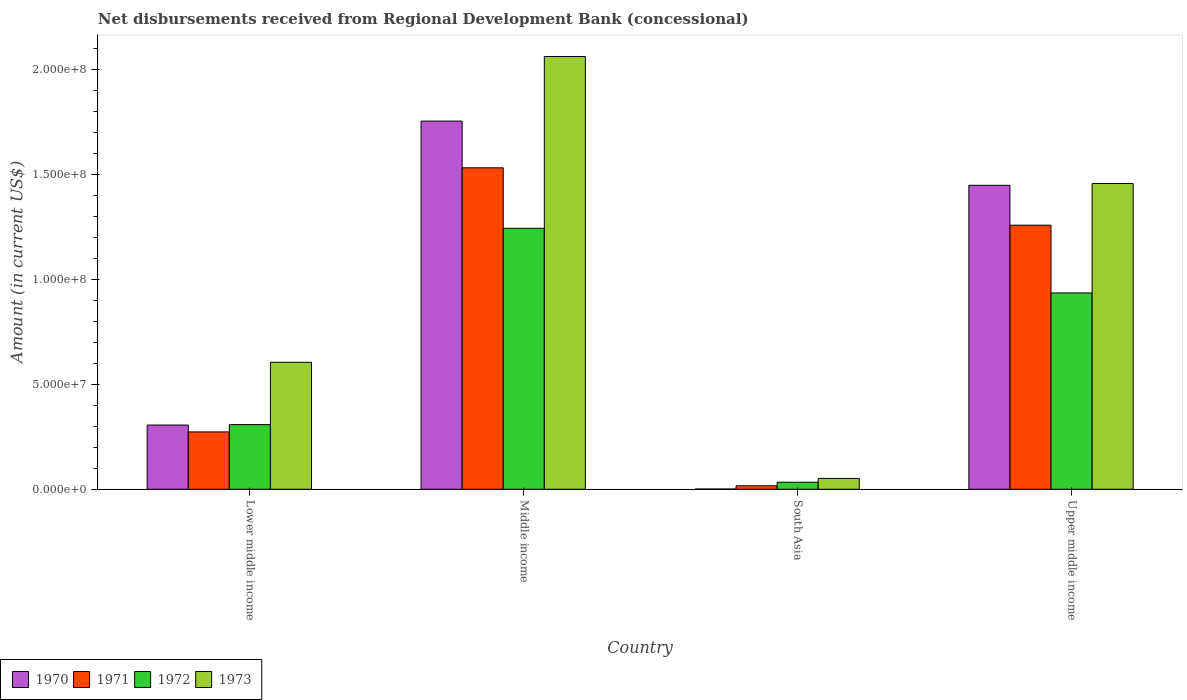Are the number of bars per tick equal to the number of legend labels?
Your answer should be compact. Yes. How many bars are there on the 1st tick from the right?
Your answer should be compact. 4. What is the amount of disbursements received from Regional Development Bank in 1972 in South Asia?
Your answer should be compact. 3.35e+06. Across all countries, what is the maximum amount of disbursements received from Regional Development Bank in 1970?
Your answer should be compact. 1.76e+08. Across all countries, what is the minimum amount of disbursements received from Regional Development Bank in 1970?
Keep it short and to the point. 1.09e+05. In which country was the amount of disbursements received from Regional Development Bank in 1973 minimum?
Your answer should be compact. South Asia. What is the total amount of disbursements received from Regional Development Bank in 1970 in the graph?
Give a very brief answer. 3.51e+08. What is the difference between the amount of disbursements received from Regional Development Bank in 1972 in Middle income and that in Upper middle income?
Your answer should be very brief. 3.08e+07. What is the difference between the amount of disbursements received from Regional Development Bank in 1971 in Upper middle income and the amount of disbursements received from Regional Development Bank in 1970 in Middle income?
Give a very brief answer. -4.96e+07. What is the average amount of disbursements received from Regional Development Bank in 1971 per country?
Offer a very short reply. 7.70e+07. What is the difference between the amount of disbursements received from Regional Development Bank of/in 1971 and amount of disbursements received from Regional Development Bank of/in 1970 in South Asia?
Your answer should be very brief. 1.54e+06. What is the ratio of the amount of disbursements received from Regional Development Bank in 1970 in South Asia to that in Upper middle income?
Your answer should be very brief. 0. Is the amount of disbursements received from Regional Development Bank in 1973 in Middle income less than that in Upper middle income?
Your answer should be very brief. No. Is the difference between the amount of disbursements received from Regional Development Bank in 1971 in Middle income and Upper middle income greater than the difference between the amount of disbursements received from Regional Development Bank in 1970 in Middle income and Upper middle income?
Make the answer very short. No. What is the difference between the highest and the second highest amount of disbursements received from Regional Development Bank in 1970?
Keep it short and to the point. 1.45e+08. What is the difference between the highest and the lowest amount of disbursements received from Regional Development Bank in 1972?
Your answer should be compact. 1.21e+08. In how many countries, is the amount of disbursements received from Regional Development Bank in 1971 greater than the average amount of disbursements received from Regional Development Bank in 1971 taken over all countries?
Ensure brevity in your answer.  2. What does the 3rd bar from the left in Lower middle income represents?
Offer a very short reply. 1972. What does the 4th bar from the right in Upper middle income represents?
Your answer should be compact. 1970. Is it the case that in every country, the sum of the amount of disbursements received from Regional Development Bank in 1973 and amount of disbursements received from Regional Development Bank in 1972 is greater than the amount of disbursements received from Regional Development Bank in 1970?
Provide a short and direct response. Yes. Are all the bars in the graph horizontal?
Ensure brevity in your answer.  No. How many countries are there in the graph?
Your answer should be compact. 4. What is the difference between two consecutive major ticks on the Y-axis?
Provide a succinct answer. 5.00e+07. Does the graph contain any zero values?
Provide a succinct answer. No. How many legend labels are there?
Ensure brevity in your answer.  4. How are the legend labels stacked?
Offer a very short reply. Horizontal. What is the title of the graph?
Make the answer very short. Net disbursements received from Regional Development Bank (concessional). Does "1967" appear as one of the legend labels in the graph?
Keep it short and to the point. No. What is the label or title of the Y-axis?
Give a very brief answer. Amount (in current US$). What is the Amount (in current US$) of 1970 in Lower middle income?
Make the answer very short. 3.06e+07. What is the Amount (in current US$) in 1971 in Lower middle income?
Your response must be concise. 2.74e+07. What is the Amount (in current US$) in 1972 in Lower middle income?
Give a very brief answer. 3.08e+07. What is the Amount (in current US$) of 1973 in Lower middle income?
Offer a terse response. 6.06e+07. What is the Amount (in current US$) of 1970 in Middle income?
Offer a terse response. 1.76e+08. What is the Amount (in current US$) of 1971 in Middle income?
Provide a short and direct response. 1.53e+08. What is the Amount (in current US$) in 1972 in Middle income?
Give a very brief answer. 1.24e+08. What is the Amount (in current US$) in 1973 in Middle income?
Your response must be concise. 2.06e+08. What is the Amount (in current US$) in 1970 in South Asia?
Keep it short and to the point. 1.09e+05. What is the Amount (in current US$) of 1971 in South Asia?
Your answer should be very brief. 1.65e+06. What is the Amount (in current US$) of 1972 in South Asia?
Provide a succinct answer. 3.35e+06. What is the Amount (in current US$) of 1973 in South Asia?
Your response must be concise. 5.18e+06. What is the Amount (in current US$) in 1970 in Upper middle income?
Your answer should be very brief. 1.45e+08. What is the Amount (in current US$) of 1971 in Upper middle income?
Offer a terse response. 1.26e+08. What is the Amount (in current US$) of 1972 in Upper middle income?
Make the answer very short. 9.36e+07. What is the Amount (in current US$) in 1973 in Upper middle income?
Provide a short and direct response. 1.46e+08. Across all countries, what is the maximum Amount (in current US$) in 1970?
Keep it short and to the point. 1.76e+08. Across all countries, what is the maximum Amount (in current US$) in 1971?
Offer a very short reply. 1.53e+08. Across all countries, what is the maximum Amount (in current US$) in 1972?
Your response must be concise. 1.24e+08. Across all countries, what is the maximum Amount (in current US$) of 1973?
Provide a succinct answer. 2.06e+08. Across all countries, what is the minimum Amount (in current US$) of 1970?
Make the answer very short. 1.09e+05. Across all countries, what is the minimum Amount (in current US$) in 1971?
Give a very brief answer. 1.65e+06. Across all countries, what is the minimum Amount (in current US$) of 1972?
Make the answer very short. 3.35e+06. Across all countries, what is the minimum Amount (in current US$) in 1973?
Give a very brief answer. 5.18e+06. What is the total Amount (in current US$) of 1970 in the graph?
Give a very brief answer. 3.51e+08. What is the total Amount (in current US$) of 1971 in the graph?
Offer a very short reply. 3.08e+08. What is the total Amount (in current US$) of 1972 in the graph?
Your answer should be compact. 2.52e+08. What is the total Amount (in current US$) in 1973 in the graph?
Your answer should be very brief. 4.18e+08. What is the difference between the Amount (in current US$) in 1970 in Lower middle income and that in Middle income?
Your answer should be compact. -1.45e+08. What is the difference between the Amount (in current US$) of 1971 in Lower middle income and that in Middle income?
Provide a succinct answer. -1.26e+08. What is the difference between the Amount (in current US$) in 1972 in Lower middle income and that in Middle income?
Provide a short and direct response. -9.36e+07. What is the difference between the Amount (in current US$) in 1973 in Lower middle income and that in Middle income?
Your answer should be very brief. -1.46e+08. What is the difference between the Amount (in current US$) in 1970 in Lower middle income and that in South Asia?
Your answer should be very brief. 3.05e+07. What is the difference between the Amount (in current US$) of 1971 in Lower middle income and that in South Asia?
Provide a short and direct response. 2.57e+07. What is the difference between the Amount (in current US$) in 1972 in Lower middle income and that in South Asia?
Provide a succinct answer. 2.75e+07. What is the difference between the Amount (in current US$) of 1973 in Lower middle income and that in South Asia?
Offer a very short reply. 5.54e+07. What is the difference between the Amount (in current US$) in 1970 in Lower middle income and that in Upper middle income?
Ensure brevity in your answer.  -1.14e+08. What is the difference between the Amount (in current US$) of 1971 in Lower middle income and that in Upper middle income?
Give a very brief answer. -9.86e+07. What is the difference between the Amount (in current US$) of 1972 in Lower middle income and that in Upper middle income?
Ensure brevity in your answer.  -6.28e+07. What is the difference between the Amount (in current US$) in 1973 in Lower middle income and that in Upper middle income?
Your answer should be compact. -8.52e+07. What is the difference between the Amount (in current US$) of 1970 in Middle income and that in South Asia?
Make the answer very short. 1.75e+08. What is the difference between the Amount (in current US$) of 1971 in Middle income and that in South Asia?
Keep it short and to the point. 1.52e+08. What is the difference between the Amount (in current US$) of 1972 in Middle income and that in South Asia?
Provide a short and direct response. 1.21e+08. What is the difference between the Amount (in current US$) in 1973 in Middle income and that in South Asia?
Offer a terse response. 2.01e+08. What is the difference between the Amount (in current US$) in 1970 in Middle income and that in Upper middle income?
Your response must be concise. 3.06e+07. What is the difference between the Amount (in current US$) in 1971 in Middle income and that in Upper middle income?
Offer a terse response. 2.74e+07. What is the difference between the Amount (in current US$) of 1972 in Middle income and that in Upper middle income?
Your answer should be compact. 3.08e+07. What is the difference between the Amount (in current US$) of 1973 in Middle income and that in Upper middle income?
Offer a terse response. 6.06e+07. What is the difference between the Amount (in current US$) in 1970 in South Asia and that in Upper middle income?
Your answer should be compact. -1.45e+08. What is the difference between the Amount (in current US$) in 1971 in South Asia and that in Upper middle income?
Offer a very short reply. -1.24e+08. What is the difference between the Amount (in current US$) of 1972 in South Asia and that in Upper middle income?
Your answer should be compact. -9.03e+07. What is the difference between the Amount (in current US$) of 1973 in South Asia and that in Upper middle income?
Give a very brief answer. -1.41e+08. What is the difference between the Amount (in current US$) in 1970 in Lower middle income and the Amount (in current US$) in 1971 in Middle income?
Offer a terse response. -1.23e+08. What is the difference between the Amount (in current US$) in 1970 in Lower middle income and the Amount (in current US$) in 1972 in Middle income?
Give a very brief answer. -9.38e+07. What is the difference between the Amount (in current US$) of 1970 in Lower middle income and the Amount (in current US$) of 1973 in Middle income?
Ensure brevity in your answer.  -1.76e+08. What is the difference between the Amount (in current US$) of 1971 in Lower middle income and the Amount (in current US$) of 1972 in Middle income?
Your response must be concise. -9.71e+07. What is the difference between the Amount (in current US$) of 1971 in Lower middle income and the Amount (in current US$) of 1973 in Middle income?
Offer a terse response. -1.79e+08. What is the difference between the Amount (in current US$) of 1972 in Lower middle income and the Amount (in current US$) of 1973 in Middle income?
Make the answer very short. -1.76e+08. What is the difference between the Amount (in current US$) of 1970 in Lower middle income and the Amount (in current US$) of 1971 in South Asia?
Keep it short and to the point. 2.90e+07. What is the difference between the Amount (in current US$) of 1970 in Lower middle income and the Amount (in current US$) of 1972 in South Asia?
Provide a short and direct response. 2.73e+07. What is the difference between the Amount (in current US$) in 1970 in Lower middle income and the Amount (in current US$) in 1973 in South Asia?
Offer a very short reply. 2.54e+07. What is the difference between the Amount (in current US$) of 1971 in Lower middle income and the Amount (in current US$) of 1972 in South Asia?
Make the answer very short. 2.40e+07. What is the difference between the Amount (in current US$) of 1971 in Lower middle income and the Amount (in current US$) of 1973 in South Asia?
Your answer should be compact. 2.22e+07. What is the difference between the Amount (in current US$) of 1972 in Lower middle income and the Amount (in current US$) of 1973 in South Asia?
Offer a very short reply. 2.56e+07. What is the difference between the Amount (in current US$) of 1970 in Lower middle income and the Amount (in current US$) of 1971 in Upper middle income?
Your answer should be very brief. -9.53e+07. What is the difference between the Amount (in current US$) of 1970 in Lower middle income and the Amount (in current US$) of 1972 in Upper middle income?
Provide a succinct answer. -6.30e+07. What is the difference between the Amount (in current US$) of 1970 in Lower middle income and the Amount (in current US$) of 1973 in Upper middle income?
Offer a very short reply. -1.15e+08. What is the difference between the Amount (in current US$) in 1971 in Lower middle income and the Amount (in current US$) in 1972 in Upper middle income?
Make the answer very short. -6.63e+07. What is the difference between the Amount (in current US$) of 1971 in Lower middle income and the Amount (in current US$) of 1973 in Upper middle income?
Give a very brief answer. -1.18e+08. What is the difference between the Amount (in current US$) of 1972 in Lower middle income and the Amount (in current US$) of 1973 in Upper middle income?
Keep it short and to the point. -1.15e+08. What is the difference between the Amount (in current US$) of 1970 in Middle income and the Amount (in current US$) of 1971 in South Asia?
Offer a very short reply. 1.74e+08. What is the difference between the Amount (in current US$) in 1970 in Middle income and the Amount (in current US$) in 1972 in South Asia?
Offer a terse response. 1.72e+08. What is the difference between the Amount (in current US$) in 1970 in Middle income and the Amount (in current US$) in 1973 in South Asia?
Give a very brief answer. 1.70e+08. What is the difference between the Amount (in current US$) in 1971 in Middle income and the Amount (in current US$) in 1972 in South Asia?
Keep it short and to the point. 1.50e+08. What is the difference between the Amount (in current US$) in 1971 in Middle income and the Amount (in current US$) in 1973 in South Asia?
Your response must be concise. 1.48e+08. What is the difference between the Amount (in current US$) of 1972 in Middle income and the Amount (in current US$) of 1973 in South Asia?
Ensure brevity in your answer.  1.19e+08. What is the difference between the Amount (in current US$) in 1970 in Middle income and the Amount (in current US$) in 1971 in Upper middle income?
Provide a succinct answer. 4.96e+07. What is the difference between the Amount (in current US$) of 1970 in Middle income and the Amount (in current US$) of 1972 in Upper middle income?
Your response must be concise. 8.19e+07. What is the difference between the Amount (in current US$) of 1970 in Middle income and the Amount (in current US$) of 1973 in Upper middle income?
Give a very brief answer. 2.98e+07. What is the difference between the Amount (in current US$) of 1971 in Middle income and the Amount (in current US$) of 1972 in Upper middle income?
Offer a very short reply. 5.97e+07. What is the difference between the Amount (in current US$) of 1971 in Middle income and the Amount (in current US$) of 1973 in Upper middle income?
Provide a short and direct response. 7.49e+06. What is the difference between the Amount (in current US$) in 1972 in Middle income and the Amount (in current US$) in 1973 in Upper middle income?
Your answer should be compact. -2.14e+07. What is the difference between the Amount (in current US$) of 1970 in South Asia and the Amount (in current US$) of 1971 in Upper middle income?
Make the answer very short. -1.26e+08. What is the difference between the Amount (in current US$) of 1970 in South Asia and the Amount (in current US$) of 1972 in Upper middle income?
Ensure brevity in your answer.  -9.35e+07. What is the difference between the Amount (in current US$) in 1970 in South Asia and the Amount (in current US$) in 1973 in Upper middle income?
Offer a very short reply. -1.46e+08. What is the difference between the Amount (in current US$) of 1971 in South Asia and the Amount (in current US$) of 1972 in Upper middle income?
Your response must be concise. -9.20e+07. What is the difference between the Amount (in current US$) of 1971 in South Asia and the Amount (in current US$) of 1973 in Upper middle income?
Make the answer very short. -1.44e+08. What is the difference between the Amount (in current US$) in 1972 in South Asia and the Amount (in current US$) in 1973 in Upper middle income?
Your response must be concise. -1.42e+08. What is the average Amount (in current US$) of 1970 per country?
Make the answer very short. 8.78e+07. What is the average Amount (in current US$) of 1971 per country?
Offer a very short reply. 7.70e+07. What is the average Amount (in current US$) of 1972 per country?
Keep it short and to the point. 6.31e+07. What is the average Amount (in current US$) of 1973 per country?
Offer a very short reply. 1.04e+08. What is the difference between the Amount (in current US$) of 1970 and Amount (in current US$) of 1971 in Lower middle income?
Your response must be concise. 3.27e+06. What is the difference between the Amount (in current US$) in 1970 and Amount (in current US$) in 1972 in Lower middle income?
Provide a succinct answer. -2.02e+05. What is the difference between the Amount (in current US$) of 1970 and Amount (in current US$) of 1973 in Lower middle income?
Your answer should be very brief. -2.99e+07. What is the difference between the Amount (in current US$) of 1971 and Amount (in current US$) of 1972 in Lower middle income?
Make the answer very short. -3.47e+06. What is the difference between the Amount (in current US$) in 1971 and Amount (in current US$) in 1973 in Lower middle income?
Offer a very short reply. -3.32e+07. What is the difference between the Amount (in current US$) in 1972 and Amount (in current US$) in 1973 in Lower middle income?
Ensure brevity in your answer.  -2.97e+07. What is the difference between the Amount (in current US$) in 1970 and Amount (in current US$) in 1971 in Middle income?
Make the answer very short. 2.23e+07. What is the difference between the Amount (in current US$) of 1970 and Amount (in current US$) of 1972 in Middle income?
Provide a short and direct response. 5.11e+07. What is the difference between the Amount (in current US$) in 1970 and Amount (in current US$) in 1973 in Middle income?
Your response must be concise. -3.08e+07. What is the difference between the Amount (in current US$) in 1971 and Amount (in current US$) in 1972 in Middle income?
Ensure brevity in your answer.  2.88e+07. What is the difference between the Amount (in current US$) of 1971 and Amount (in current US$) of 1973 in Middle income?
Offer a terse response. -5.31e+07. What is the difference between the Amount (in current US$) in 1972 and Amount (in current US$) in 1973 in Middle income?
Ensure brevity in your answer.  -8.19e+07. What is the difference between the Amount (in current US$) of 1970 and Amount (in current US$) of 1971 in South Asia?
Your answer should be very brief. -1.54e+06. What is the difference between the Amount (in current US$) of 1970 and Amount (in current US$) of 1972 in South Asia?
Ensure brevity in your answer.  -3.24e+06. What is the difference between the Amount (in current US$) of 1970 and Amount (in current US$) of 1973 in South Asia?
Offer a terse response. -5.08e+06. What is the difference between the Amount (in current US$) in 1971 and Amount (in current US$) in 1972 in South Asia?
Offer a very short reply. -1.70e+06. What is the difference between the Amount (in current US$) of 1971 and Amount (in current US$) of 1973 in South Asia?
Give a very brief answer. -3.53e+06. What is the difference between the Amount (in current US$) in 1972 and Amount (in current US$) in 1973 in South Asia?
Your answer should be very brief. -1.83e+06. What is the difference between the Amount (in current US$) of 1970 and Amount (in current US$) of 1971 in Upper middle income?
Keep it short and to the point. 1.90e+07. What is the difference between the Amount (in current US$) in 1970 and Amount (in current US$) in 1972 in Upper middle income?
Provide a short and direct response. 5.13e+07. What is the difference between the Amount (in current US$) of 1970 and Amount (in current US$) of 1973 in Upper middle income?
Make the answer very short. -8.58e+05. What is the difference between the Amount (in current US$) in 1971 and Amount (in current US$) in 1972 in Upper middle income?
Make the answer very short. 3.23e+07. What is the difference between the Amount (in current US$) in 1971 and Amount (in current US$) in 1973 in Upper middle income?
Provide a succinct answer. -1.99e+07. What is the difference between the Amount (in current US$) of 1972 and Amount (in current US$) of 1973 in Upper middle income?
Offer a very short reply. -5.22e+07. What is the ratio of the Amount (in current US$) of 1970 in Lower middle income to that in Middle income?
Your response must be concise. 0.17. What is the ratio of the Amount (in current US$) of 1971 in Lower middle income to that in Middle income?
Provide a succinct answer. 0.18. What is the ratio of the Amount (in current US$) in 1972 in Lower middle income to that in Middle income?
Offer a very short reply. 0.25. What is the ratio of the Amount (in current US$) in 1973 in Lower middle income to that in Middle income?
Give a very brief answer. 0.29. What is the ratio of the Amount (in current US$) of 1970 in Lower middle income to that in South Asia?
Offer a very short reply. 280.94. What is the ratio of the Amount (in current US$) in 1971 in Lower middle income to that in South Asia?
Provide a succinct answer. 16.58. What is the ratio of the Amount (in current US$) in 1972 in Lower middle income to that in South Asia?
Make the answer very short. 9.2. What is the ratio of the Amount (in current US$) in 1973 in Lower middle income to that in South Asia?
Offer a very short reply. 11.68. What is the ratio of the Amount (in current US$) of 1970 in Lower middle income to that in Upper middle income?
Offer a terse response. 0.21. What is the ratio of the Amount (in current US$) in 1971 in Lower middle income to that in Upper middle income?
Make the answer very short. 0.22. What is the ratio of the Amount (in current US$) of 1972 in Lower middle income to that in Upper middle income?
Give a very brief answer. 0.33. What is the ratio of the Amount (in current US$) of 1973 in Lower middle income to that in Upper middle income?
Give a very brief answer. 0.42. What is the ratio of the Amount (in current US$) in 1970 in Middle income to that in South Asia?
Your response must be concise. 1610.58. What is the ratio of the Amount (in current US$) of 1971 in Middle income to that in South Asia?
Your answer should be compact. 92.89. What is the ratio of the Amount (in current US$) in 1972 in Middle income to that in South Asia?
Your answer should be compact. 37.14. What is the ratio of the Amount (in current US$) of 1973 in Middle income to that in South Asia?
Offer a terse response. 39.8. What is the ratio of the Amount (in current US$) of 1970 in Middle income to that in Upper middle income?
Give a very brief answer. 1.21. What is the ratio of the Amount (in current US$) in 1971 in Middle income to that in Upper middle income?
Your answer should be very brief. 1.22. What is the ratio of the Amount (in current US$) of 1972 in Middle income to that in Upper middle income?
Offer a terse response. 1.33. What is the ratio of the Amount (in current US$) in 1973 in Middle income to that in Upper middle income?
Ensure brevity in your answer.  1.42. What is the ratio of the Amount (in current US$) in 1970 in South Asia to that in Upper middle income?
Give a very brief answer. 0. What is the ratio of the Amount (in current US$) in 1971 in South Asia to that in Upper middle income?
Your answer should be very brief. 0.01. What is the ratio of the Amount (in current US$) of 1972 in South Asia to that in Upper middle income?
Provide a succinct answer. 0.04. What is the ratio of the Amount (in current US$) of 1973 in South Asia to that in Upper middle income?
Give a very brief answer. 0.04. What is the difference between the highest and the second highest Amount (in current US$) in 1970?
Give a very brief answer. 3.06e+07. What is the difference between the highest and the second highest Amount (in current US$) in 1971?
Provide a succinct answer. 2.74e+07. What is the difference between the highest and the second highest Amount (in current US$) of 1972?
Provide a succinct answer. 3.08e+07. What is the difference between the highest and the second highest Amount (in current US$) of 1973?
Provide a short and direct response. 6.06e+07. What is the difference between the highest and the lowest Amount (in current US$) of 1970?
Keep it short and to the point. 1.75e+08. What is the difference between the highest and the lowest Amount (in current US$) in 1971?
Give a very brief answer. 1.52e+08. What is the difference between the highest and the lowest Amount (in current US$) of 1972?
Your answer should be very brief. 1.21e+08. What is the difference between the highest and the lowest Amount (in current US$) of 1973?
Provide a succinct answer. 2.01e+08. 